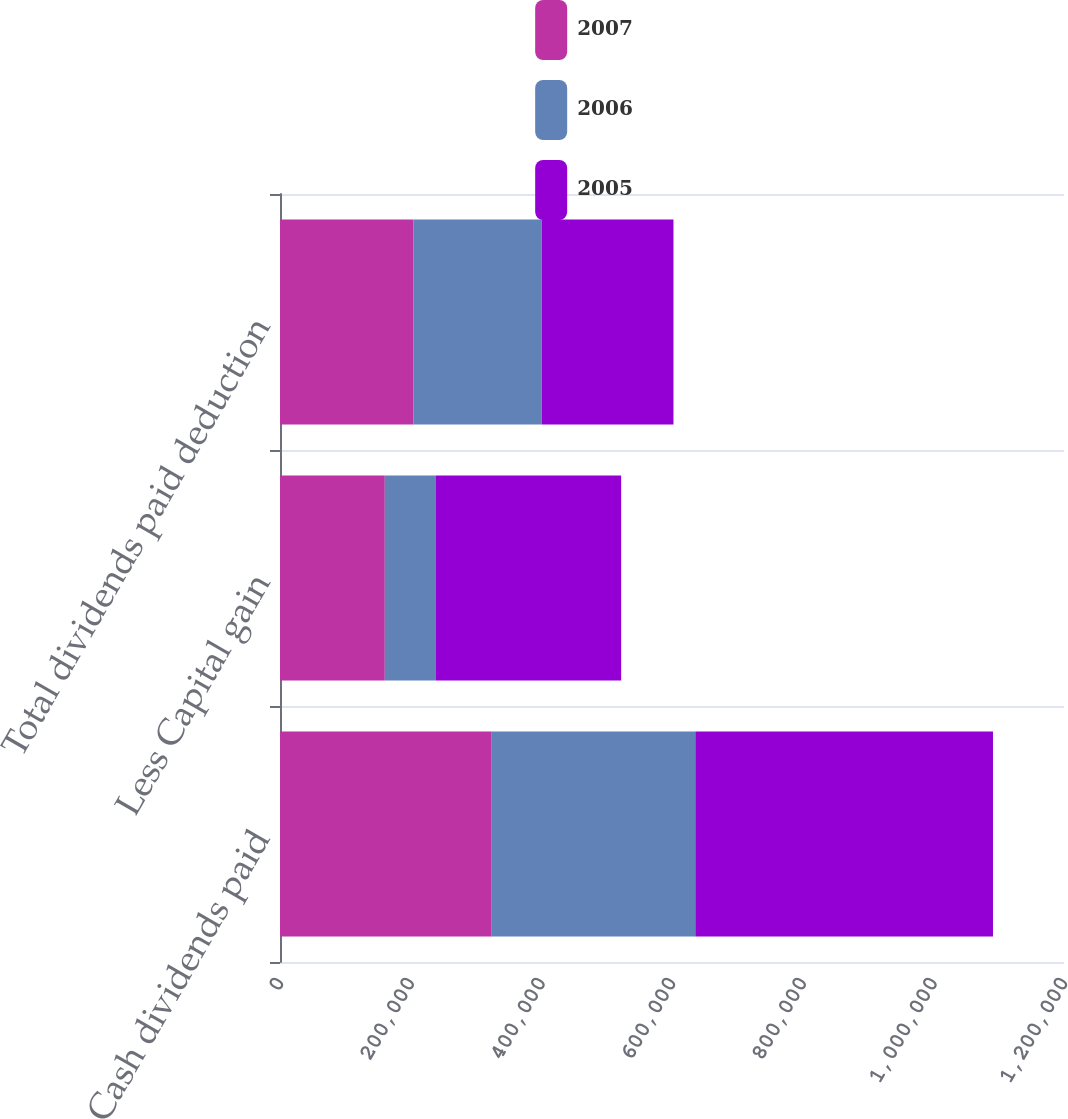Convert chart to OTSL. <chart><loc_0><loc_0><loc_500><loc_500><stacked_bar_chart><ecel><fcel>Cash dividends paid<fcel>Less Capital gain<fcel>Total dividends paid deduction<nl><fcel>2007<fcel>324085<fcel>160428<fcel>203988<nl><fcel>2006<fcel>311615<fcel>78246<fcel>196569<nl><fcel>2005<fcel>455606<fcel>283498<fcel>201686<nl></chart> 